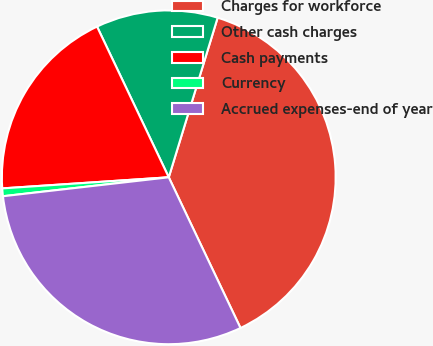<chart> <loc_0><loc_0><loc_500><loc_500><pie_chart><fcel>Charges for workforce<fcel>Other cash charges<fcel>Cash payments<fcel>Currency<fcel>Accrued expenses-end of year<nl><fcel>38.2%<fcel>11.8%<fcel>18.99%<fcel>0.75%<fcel>30.26%<nl></chart> 